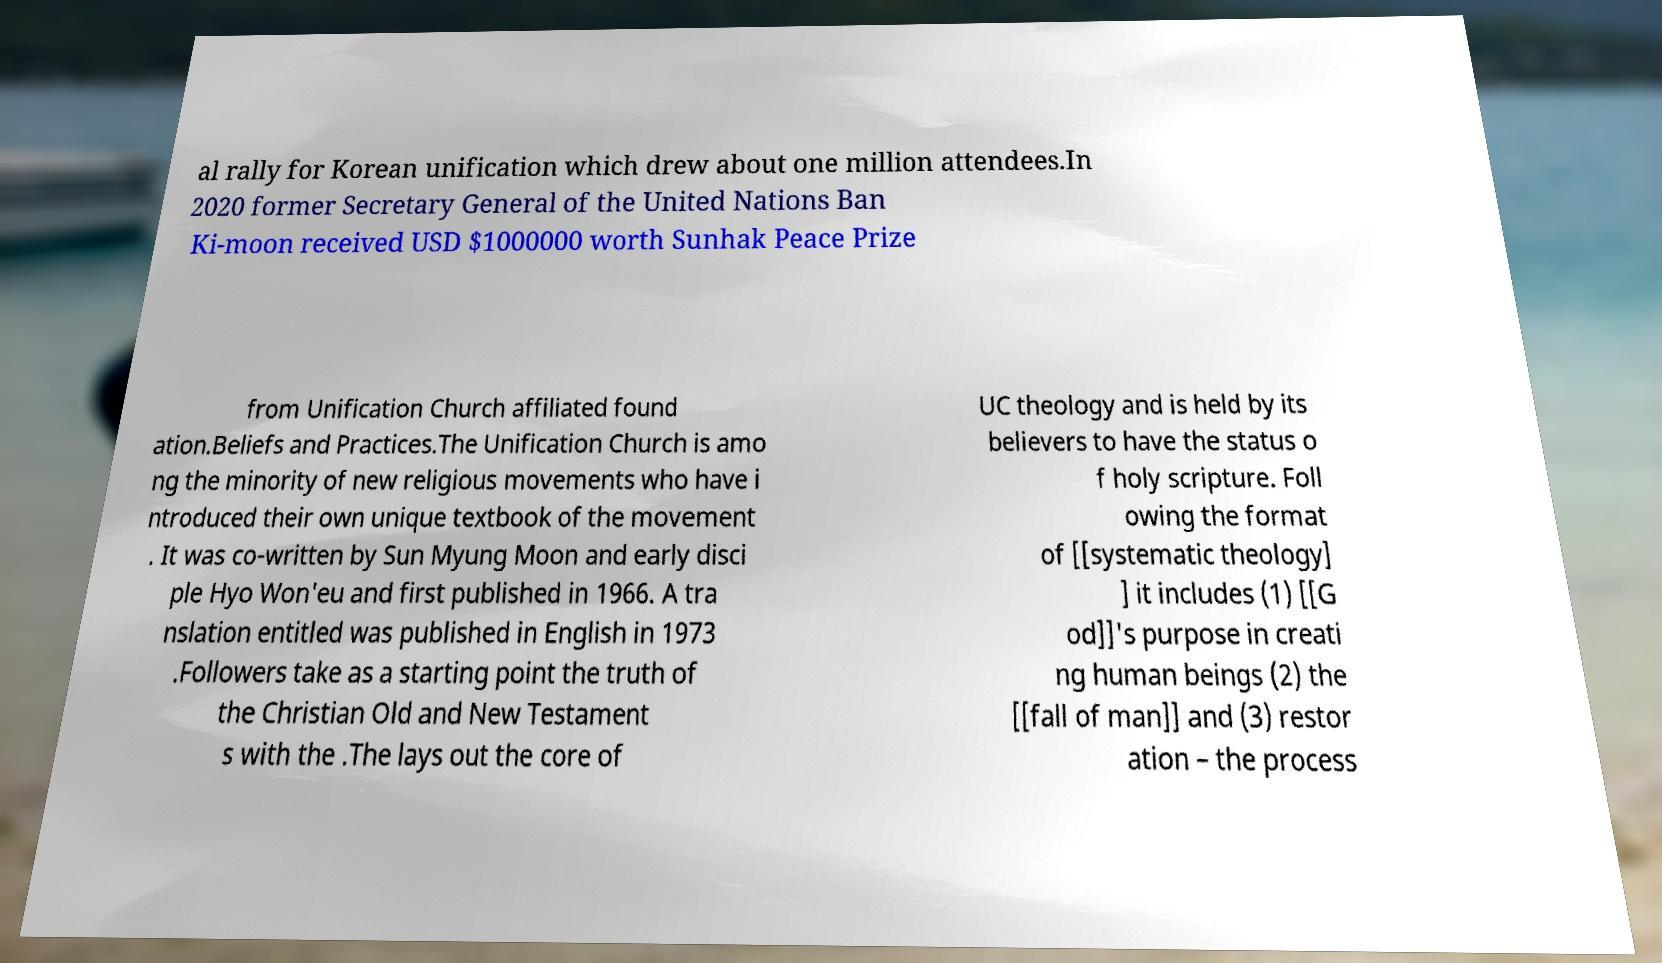What messages or text are displayed in this image? I need them in a readable, typed format. al rally for Korean unification which drew about one million attendees.In 2020 former Secretary General of the United Nations Ban Ki-moon received USD $1000000 worth Sunhak Peace Prize from Unification Church affiliated found ation.Beliefs and Practices.The Unification Church is amo ng the minority of new religious movements who have i ntroduced their own unique textbook of the movement . It was co-written by Sun Myung Moon and early disci ple Hyo Won'eu and first published in 1966. A tra nslation entitled was published in English in 1973 .Followers take as a starting point the truth of the Christian Old and New Testament s with the .The lays out the core of UC theology and is held by its believers to have the status o f holy scripture. Foll owing the format of [[systematic theology] ] it includes (1) [[G od]]'s purpose in creati ng human beings (2) the [[fall of man]] and (3) restor ation – the process 